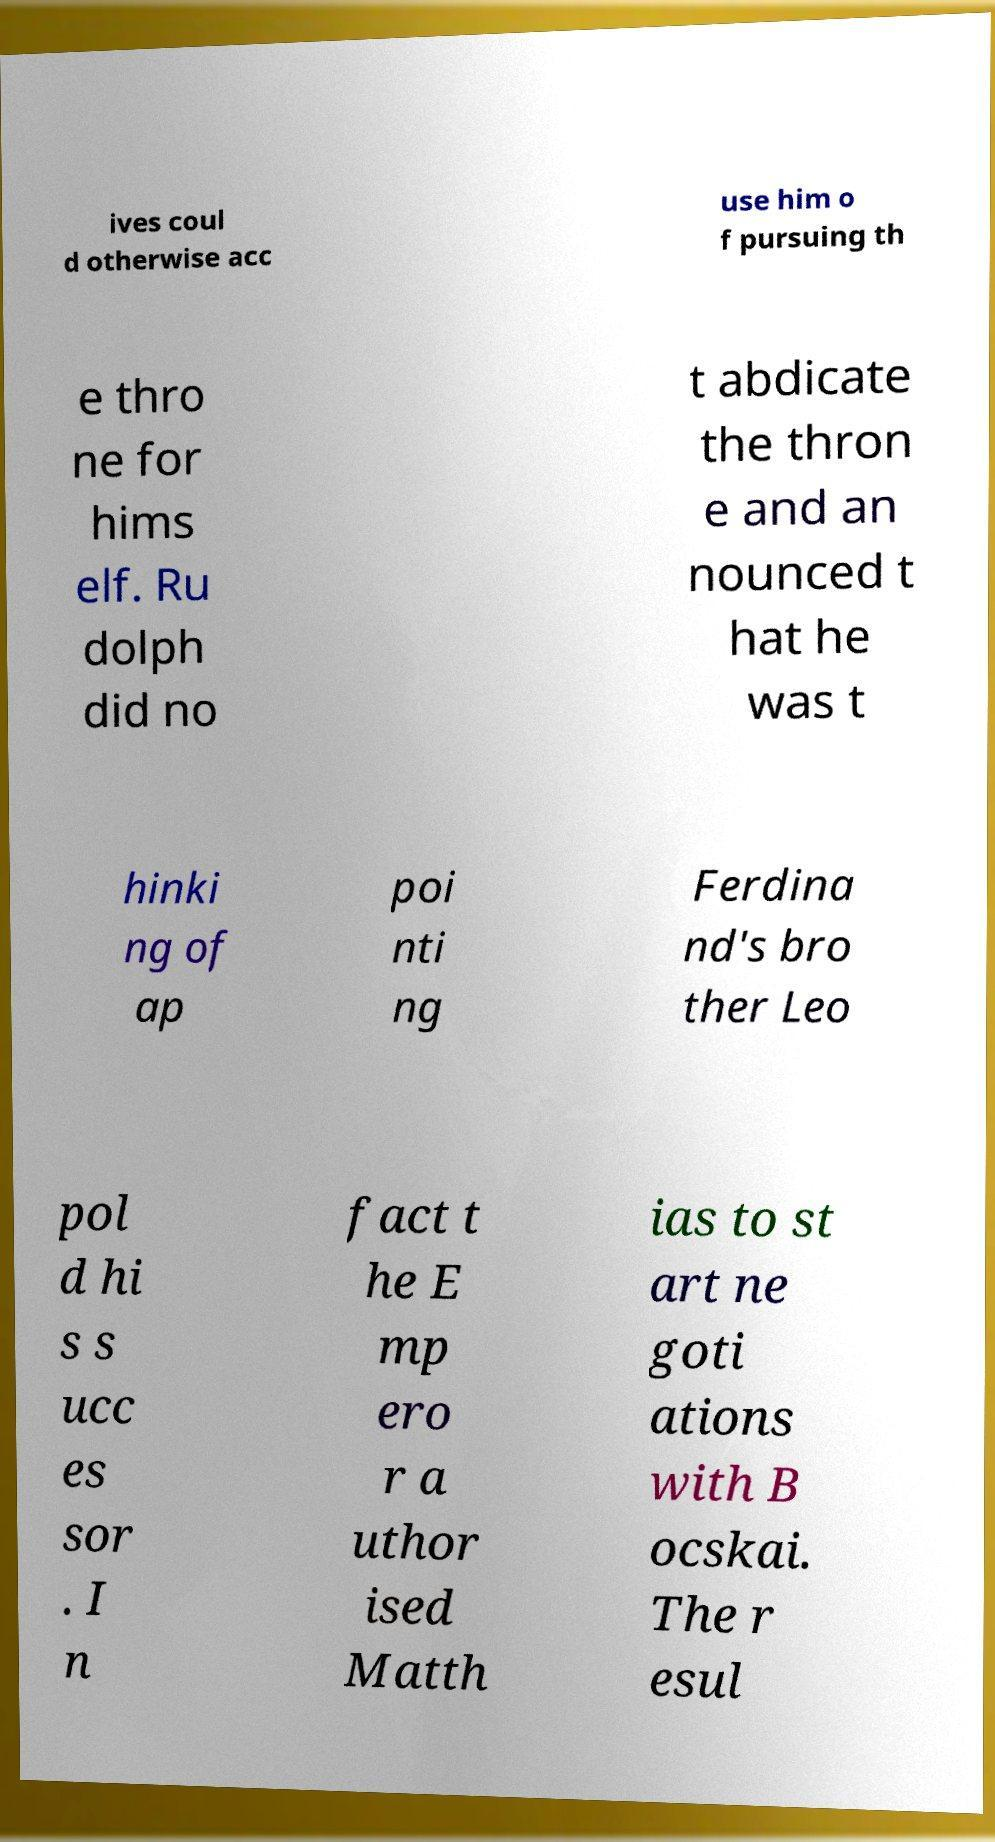Please identify and transcribe the text found in this image. ives coul d otherwise acc use him o f pursuing th e thro ne for hims elf. Ru dolph did no t abdicate the thron e and an nounced t hat he was t hinki ng of ap poi nti ng Ferdina nd's bro ther Leo pol d hi s s ucc es sor . I n fact t he E mp ero r a uthor ised Matth ias to st art ne goti ations with B ocskai. The r esul 